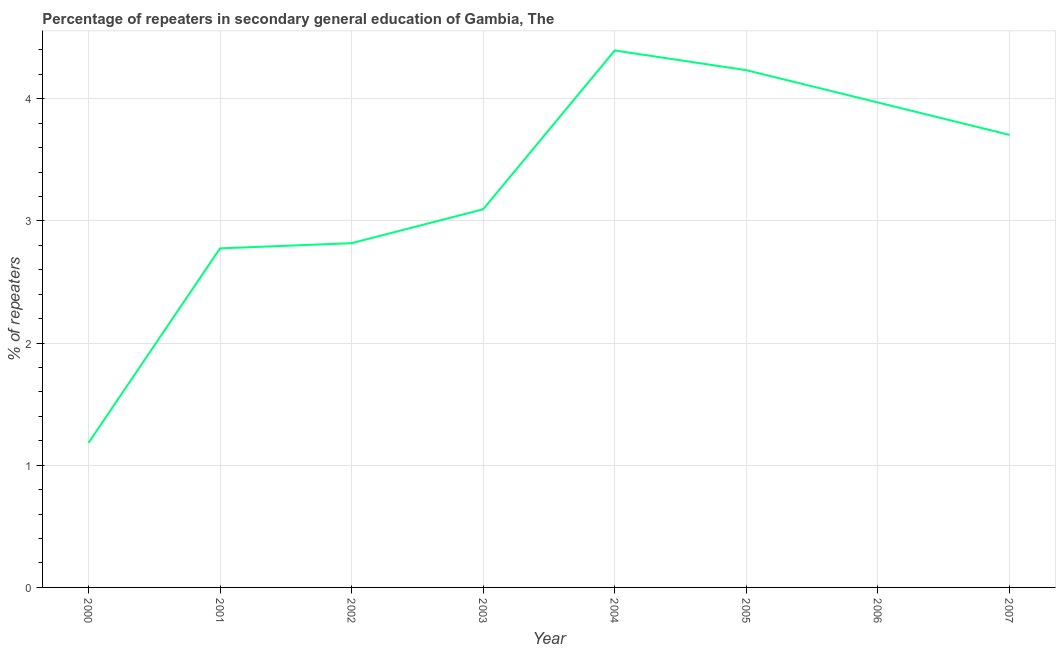What is the percentage of repeaters in 2007?
Give a very brief answer. 3.7. Across all years, what is the maximum percentage of repeaters?
Give a very brief answer. 4.4. Across all years, what is the minimum percentage of repeaters?
Ensure brevity in your answer.  1.18. In which year was the percentage of repeaters minimum?
Make the answer very short. 2000. What is the sum of the percentage of repeaters?
Offer a terse response. 26.18. What is the difference between the percentage of repeaters in 2002 and 2004?
Make the answer very short. -1.58. What is the average percentage of repeaters per year?
Provide a succinct answer. 3.27. What is the median percentage of repeaters?
Offer a very short reply. 3.4. What is the ratio of the percentage of repeaters in 2001 to that in 2003?
Keep it short and to the point. 0.9. Is the percentage of repeaters in 2000 less than that in 2007?
Give a very brief answer. Yes. Is the difference between the percentage of repeaters in 2000 and 2007 greater than the difference between any two years?
Provide a short and direct response. No. What is the difference between the highest and the second highest percentage of repeaters?
Provide a short and direct response. 0.16. Is the sum of the percentage of repeaters in 2000 and 2002 greater than the maximum percentage of repeaters across all years?
Keep it short and to the point. No. What is the difference between the highest and the lowest percentage of repeaters?
Your answer should be very brief. 3.21. In how many years, is the percentage of repeaters greater than the average percentage of repeaters taken over all years?
Provide a short and direct response. 4. Does the percentage of repeaters monotonically increase over the years?
Keep it short and to the point. No. What is the difference between two consecutive major ticks on the Y-axis?
Your response must be concise. 1. Does the graph contain grids?
Offer a very short reply. Yes. What is the title of the graph?
Your answer should be very brief. Percentage of repeaters in secondary general education of Gambia, The. What is the label or title of the X-axis?
Your response must be concise. Year. What is the label or title of the Y-axis?
Give a very brief answer. % of repeaters. What is the % of repeaters in 2000?
Keep it short and to the point. 1.18. What is the % of repeaters in 2001?
Ensure brevity in your answer.  2.78. What is the % of repeaters of 2002?
Give a very brief answer. 2.82. What is the % of repeaters of 2003?
Make the answer very short. 3.1. What is the % of repeaters in 2004?
Offer a terse response. 4.4. What is the % of repeaters in 2005?
Offer a very short reply. 4.23. What is the % of repeaters of 2006?
Your answer should be compact. 3.97. What is the % of repeaters in 2007?
Make the answer very short. 3.7. What is the difference between the % of repeaters in 2000 and 2001?
Make the answer very short. -1.59. What is the difference between the % of repeaters in 2000 and 2002?
Give a very brief answer. -1.64. What is the difference between the % of repeaters in 2000 and 2003?
Offer a terse response. -1.91. What is the difference between the % of repeaters in 2000 and 2004?
Give a very brief answer. -3.21. What is the difference between the % of repeaters in 2000 and 2005?
Offer a very short reply. -3.05. What is the difference between the % of repeaters in 2000 and 2006?
Your answer should be compact. -2.79. What is the difference between the % of repeaters in 2000 and 2007?
Ensure brevity in your answer.  -2.52. What is the difference between the % of repeaters in 2001 and 2002?
Provide a short and direct response. -0.04. What is the difference between the % of repeaters in 2001 and 2003?
Provide a succinct answer. -0.32. What is the difference between the % of repeaters in 2001 and 2004?
Provide a short and direct response. -1.62. What is the difference between the % of repeaters in 2001 and 2005?
Your answer should be very brief. -1.46. What is the difference between the % of repeaters in 2001 and 2006?
Your answer should be very brief. -1.19. What is the difference between the % of repeaters in 2001 and 2007?
Your response must be concise. -0.93. What is the difference between the % of repeaters in 2002 and 2003?
Ensure brevity in your answer.  -0.28. What is the difference between the % of repeaters in 2002 and 2004?
Provide a short and direct response. -1.58. What is the difference between the % of repeaters in 2002 and 2005?
Give a very brief answer. -1.42. What is the difference between the % of repeaters in 2002 and 2006?
Offer a terse response. -1.15. What is the difference between the % of repeaters in 2002 and 2007?
Offer a terse response. -0.89. What is the difference between the % of repeaters in 2003 and 2004?
Give a very brief answer. -1.3. What is the difference between the % of repeaters in 2003 and 2005?
Ensure brevity in your answer.  -1.14. What is the difference between the % of repeaters in 2003 and 2006?
Provide a short and direct response. -0.87. What is the difference between the % of repeaters in 2003 and 2007?
Provide a short and direct response. -0.61. What is the difference between the % of repeaters in 2004 and 2005?
Your answer should be very brief. 0.16. What is the difference between the % of repeaters in 2004 and 2006?
Keep it short and to the point. 0.43. What is the difference between the % of repeaters in 2004 and 2007?
Your answer should be very brief. 0.69. What is the difference between the % of repeaters in 2005 and 2006?
Offer a very short reply. 0.26. What is the difference between the % of repeaters in 2005 and 2007?
Your answer should be compact. 0.53. What is the difference between the % of repeaters in 2006 and 2007?
Your answer should be very brief. 0.27. What is the ratio of the % of repeaters in 2000 to that in 2001?
Give a very brief answer. 0.43. What is the ratio of the % of repeaters in 2000 to that in 2002?
Give a very brief answer. 0.42. What is the ratio of the % of repeaters in 2000 to that in 2003?
Offer a very short reply. 0.38. What is the ratio of the % of repeaters in 2000 to that in 2004?
Provide a short and direct response. 0.27. What is the ratio of the % of repeaters in 2000 to that in 2005?
Your answer should be very brief. 0.28. What is the ratio of the % of repeaters in 2000 to that in 2006?
Your response must be concise. 0.3. What is the ratio of the % of repeaters in 2000 to that in 2007?
Your response must be concise. 0.32. What is the ratio of the % of repeaters in 2001 to that in 2002?
Give a very brief answer. 0.98. What is the ratio of the % of repeaters in 2001 to that in 2003?
Your answer should be compact. 0.9. What is the ratio of the % of repeaters in 2001 to that in 2004?
Provide a short and direct response. 0.63. What is the ratio of the % of repeaters in 2001 to that in 2005?
Your answer should be very brief. 0.66. What is the ratio of the % of repeaters in 2001 to that in 2006?
Give a very brief answer. 0.7. What is the ratio of the % of repeaters in 2001 to that in 2007?
Your answer should be very brief. 0.75. What is the ratio of the % of repeaters in 2002 to that in 2003?
Your answer should be very brief. 0.91. What is the ratio of the % of repeaters in 2002 to that in 2004?
Your response must be concise. 0.64. What is the ratio of the % of repeaters in 2002 to that in 2005?
Your response must be concise. 0.67. What is the ratio of the % of repeaters in 2002 to that in 2006?
Offer a terse response. 0.71. What is the ratio of the % of repeaters in 2002 to that in 2007?
Ensure brevity in your answer.  0.76. What is the ratio of the % of repeaters in 2003 to that in 2004?
Your response must be concise. 0.7. What is the ratio of the % of repeaters in 2003 to that in 2005?
Provide a short and direct response. 0.73. What is the ratio of the % of repeaters in 2003 to that in 2006?
Offer a terse response. 0.78. What is the ratio of the % of repeaters in 2003 to that in 2007?
Give a very brief answer. 0.84. What is the ratio of the % of repeaters in 2004 to that in 2005?
Offer a very short reply. 1.04. What is the ratio of the % of repeaters in 2004 to that in 2006?
Provide a short and direct response. 1.11. What is the ratio of the % of repeaters in 2004 to that in 2007?
Your answer should be very brief. 1.19. What is the ratio of the % of repeaters in 2005 to that in 2006?
Offer a terse response. 1.07. What is the ratio of the % of repeaters in 2005 to that in 2007?
Offer a terse response. 1.14. What is the ratio of the % of repeaters in 2006 to that in 2007?
Your answer should be compact. 1.07. 